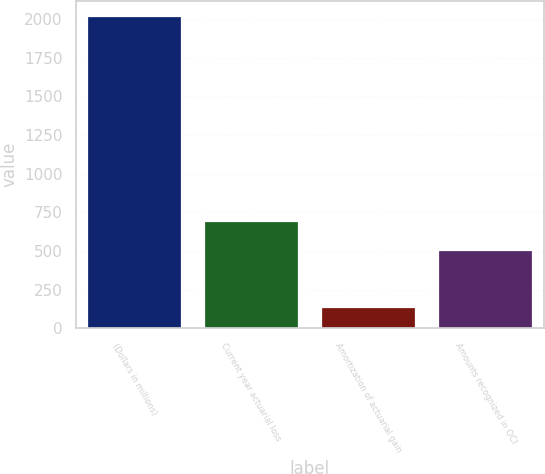Convert chart to OTSL. <chart><loc_0><loc_0><loc_500><loc_500><bar_chart><fcel>(Dollars in millions)<fcel>Current year actuarial loss<fcel>Amortization of actuarial gain<fcel>Amounts recognized in OCI<nl><fcel>2016<fcel>696.7<fcel>139<fcel>509<nl></chart> 